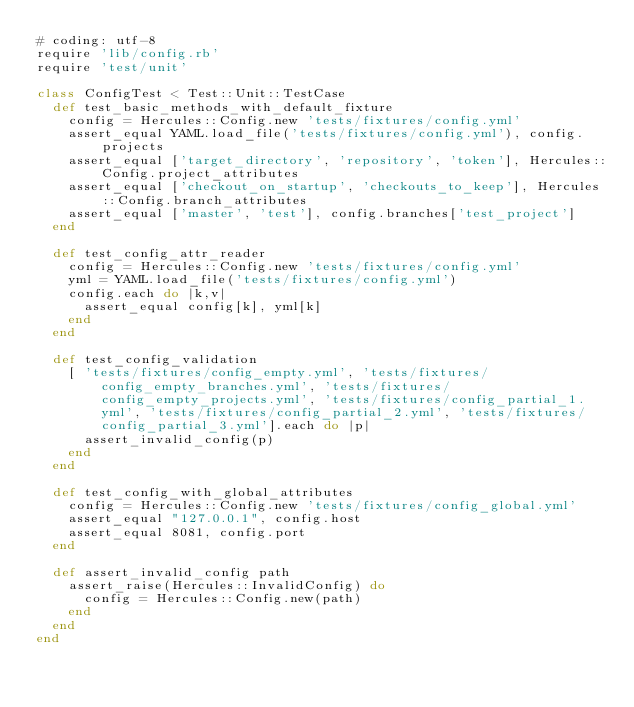<code> <loc_0><loc_0><loc_500><loc_500><_Ruby_># coding: utf-8
require 'lib/config.rb'
require 'test/unit'

class ConfigTest < Test::Unit::TestCase
  def test_basic_methods_with_default_fixture
    config = Hercules::Config.new 'tests/fixtures/config.yml'
    assert_equal YAML.load_file('tests/fixtures/config.yml'), config.projects
    assert_equal ['target_directory', 'repository', 'token'], Hercules::Config.project_attributes
    assert_equal ['checkout_on_startup', 'checkouts_to_keep'], Hercules::Config.branch_attributes
    assert_equal ['master', 'test'], config.branches['test_project']
  end

  def test_config_attr_reader
    config = Hercules::Config.new 'tests/fixtures/config.yml'
    yml = YAML.load_file('tests/fixtures/config.yml')
    config.each do |k,v|
      assert_equal config[k], yml[k]
    end
  end

  def test_config_validation
    [ 'tests/fixtures/config_empty.yml', 'tests/fixtures/config_empty_branches.yml', 'tests/fixtures/config_empty_projects.yml', 'tests/fixtures/config_partial_1.yml', 'tests/fixtures/config_partial_2.yml', 'tests/fixtures/config_partial_3.yml'].each do |p|
      assert_invalid_config(p) 
    end
  end

  def test_config_with_global_attributes
    config = Hercules::Config.new 'tests/fixtures/config_global.yml'
    assert_equal "127.0.0.1", config.host
    assert_equal 8081, config.port
  end

  def assert_invalid_config path
    assert_raise(Hercules::InvalidConfig) do
      config = Hercules::Config.new(path)
    end
  end
end
</code> 